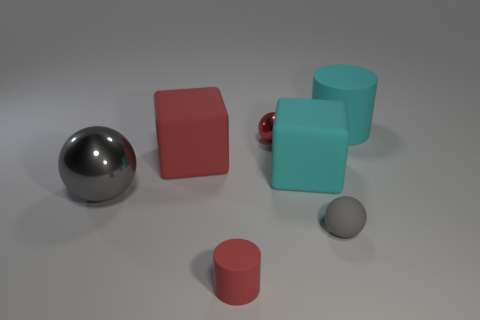Add 1 blue metallic things. How many objects exist? 8 Subtract all cylinders. How many objects are left? 5 Subtract all small red matte objects. Subtract all cyan matte cylinders. How many objects are left? 5 Add 4 gray balls. How many gray balls are left? 6 Add 1 gray rubber balls. How many gray rubber balls exist? 2 Subtract 1 red cylinders. How many objects are left? 6 